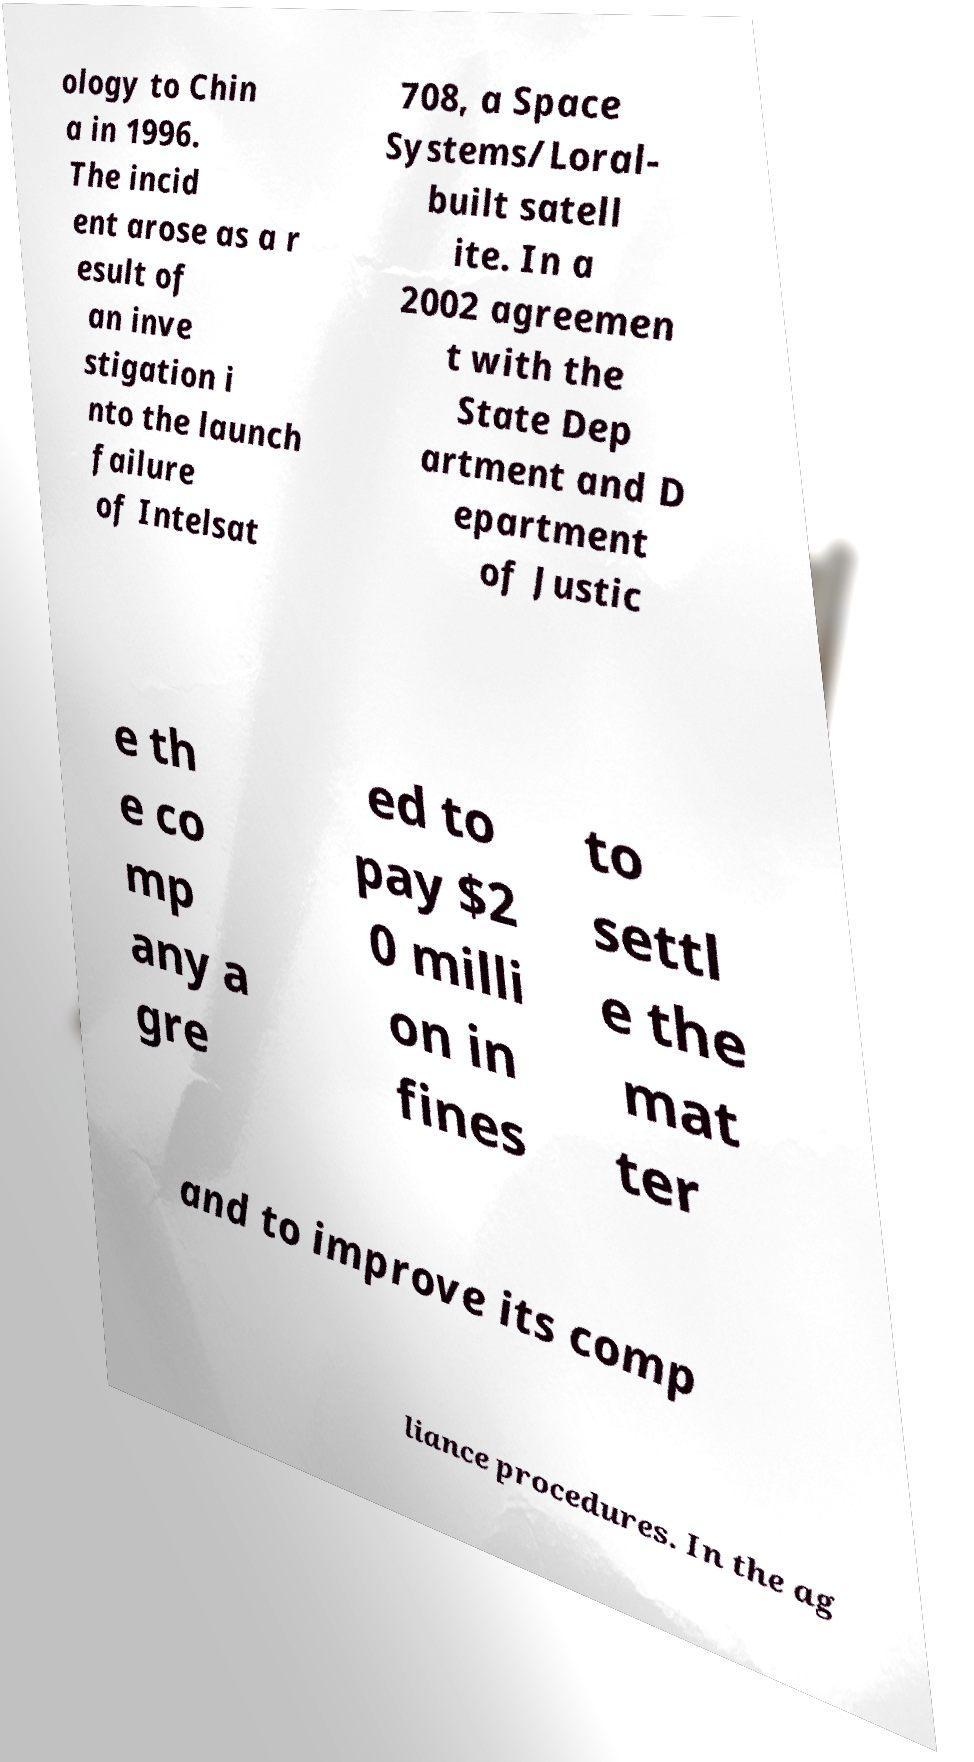Please read and relay the text visible in this image. What does it say? ology to Chin a in 1996. The incid ent arose as a r esult of an inve stigation i nto the launch failure of Intelsat 708, a Space Systems/Loral- built satell ite. In a 2002 agreemen t with the State Dep artment and D epartment of Justic e th e co mp any a gre ed to pay $2 0 milli on in fines to settl e the mat ter and to improve its comp liance procedures. In the ag 